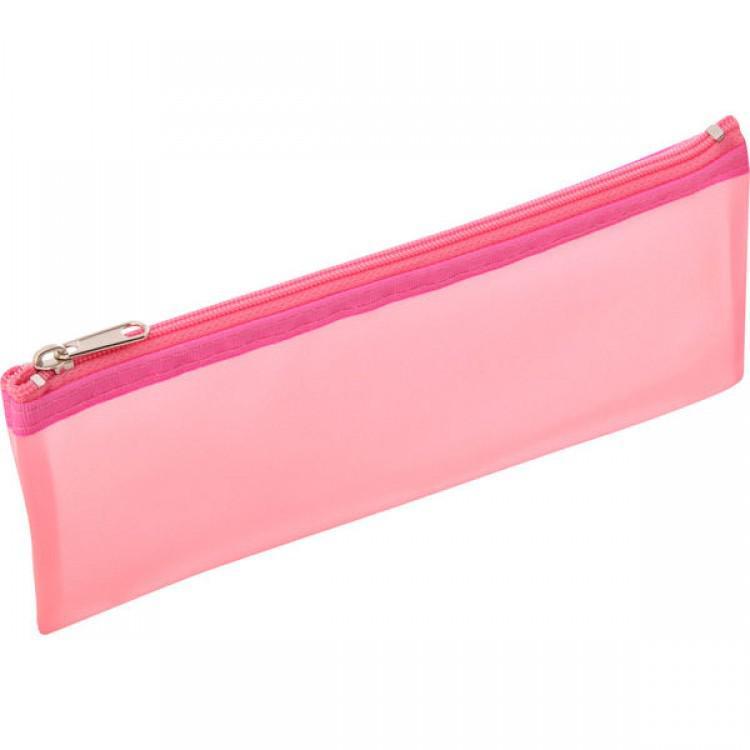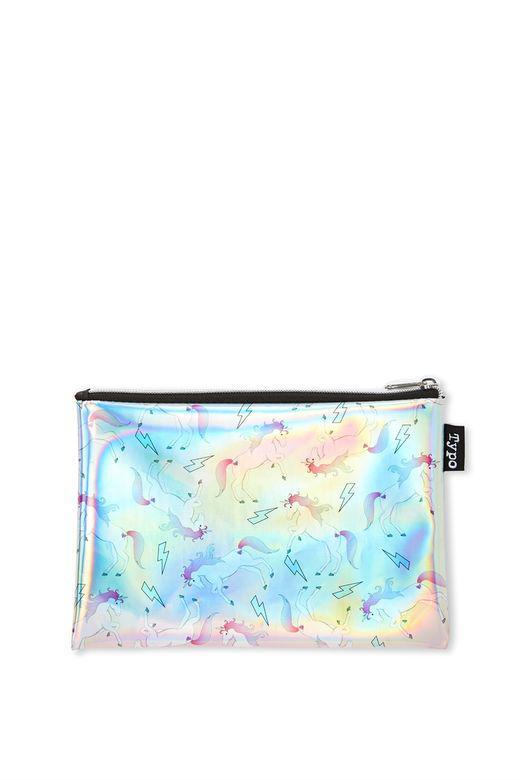The first image is the image on the left, the second image is the image on the right. Assess this claim about the two images: "There are three pencil cases in at least one of the images.". Correct or not? Answer yes or no. No. The first image is the image on the left, the second image is the image on the right. For the images displayed, is the sentence "One pencil bag has a design." factually correct? Answer yes or no. Yes. 